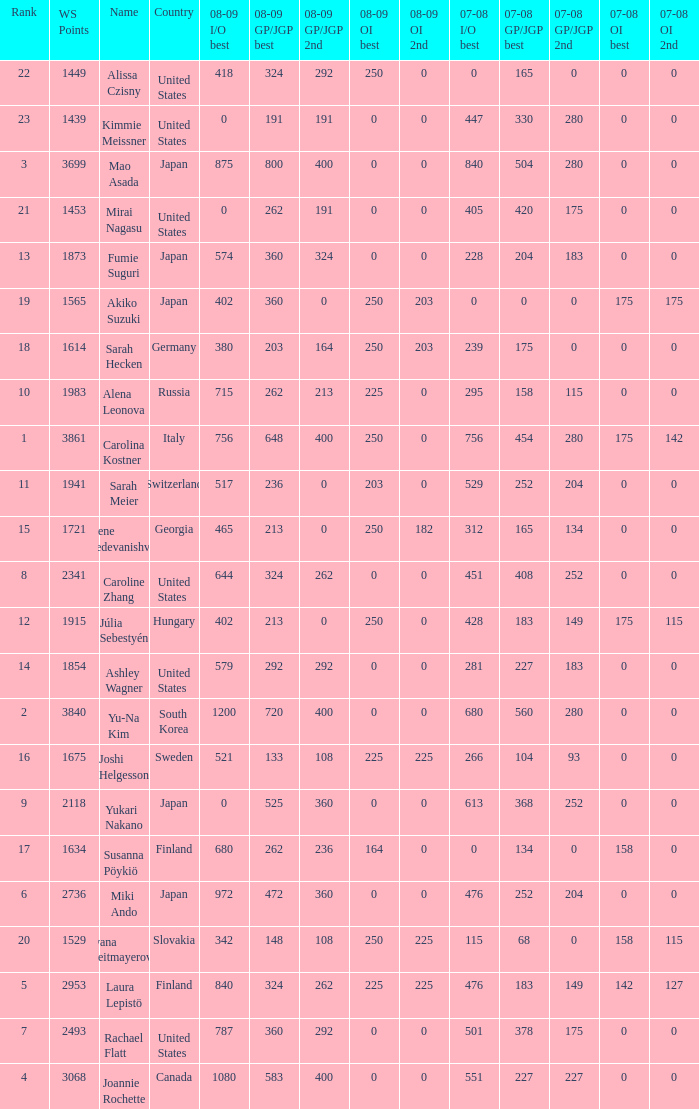08-09 gp/jgp 2nd is 213 and ws points will be what utmost? 1983.0. 